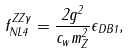Convert formula to latex. <formula><loc_0><loc_0><loc_500><loc_500>f ^ { Z Z \gamma } _ { N L 4 } = \frac { 2 g ^ { 2 } } { c _ { w } m ^ { 2 } _ { Z } } \epsilon _ { D B 1 } ,</formula> 